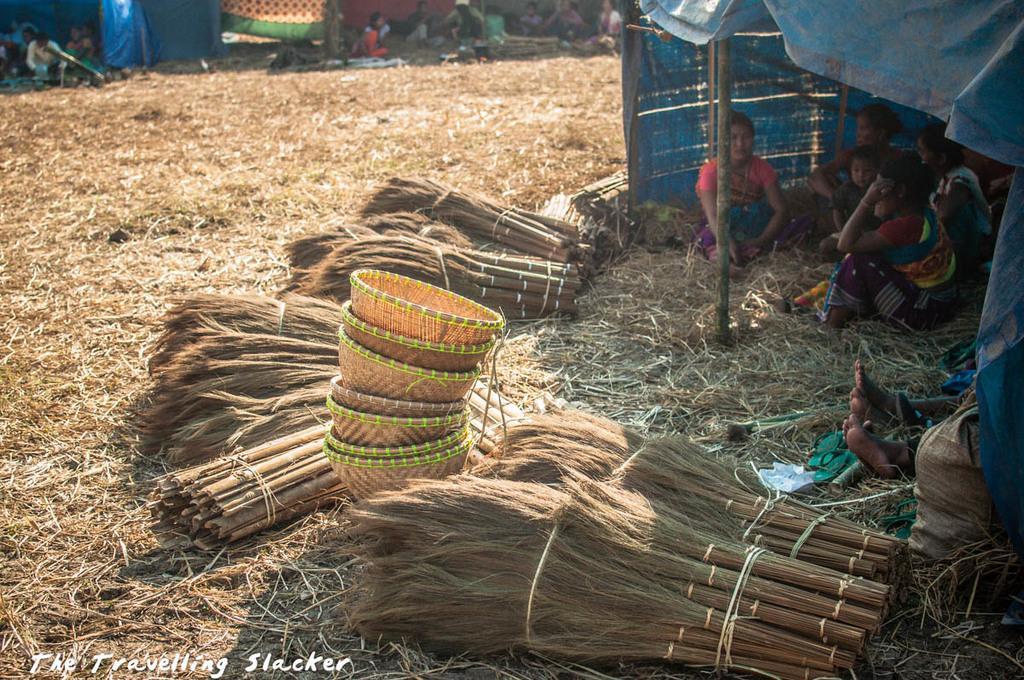Please provide a concise description of this image. In this picture we can see group of people, tents, groom sticks and baskets, in the bottom left hand corner we can see some text, on the right side of the image we can see a bag. 